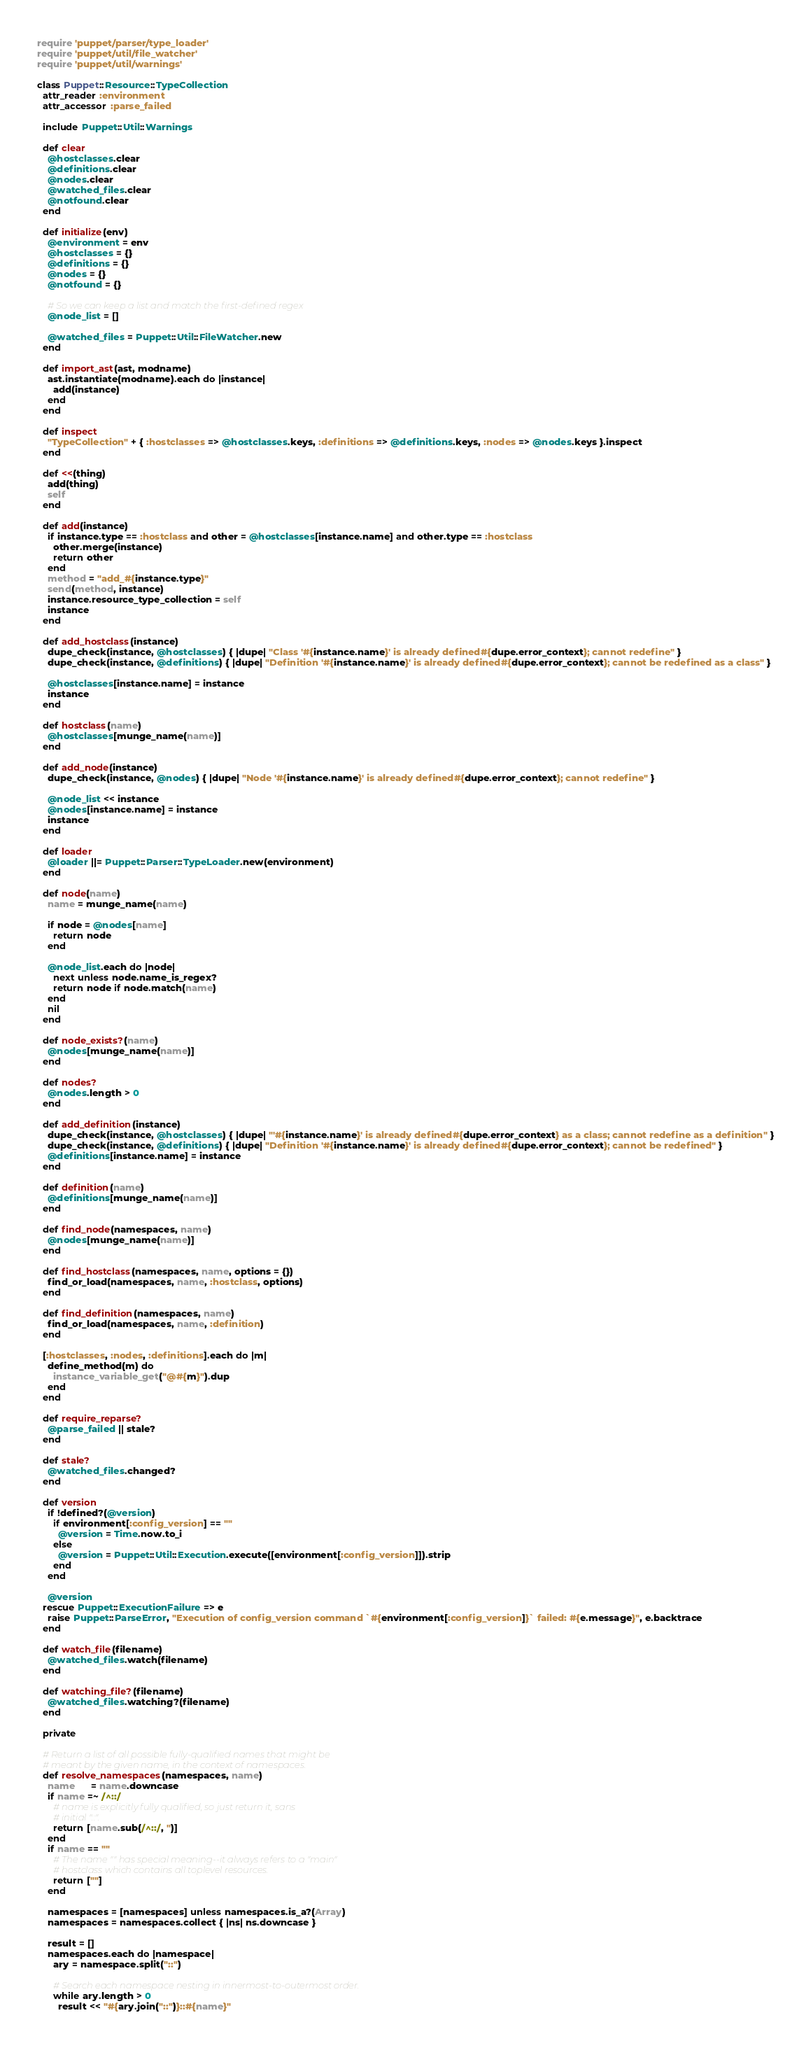<code> <loc_0><loc_0><loc_500><loc_500><_Ruby_>require 'puppet/parser/type_loader'
require 'puppet/util/file_watcher'
require 'puppet/util/warnings'

class Puppet::Resource::TypeCollection
  attr_reader :environment
  attr_accessor :parse_failed

  include Puppet::Util::Warnings

  def clear
    @hostclasses.clear
    @definitions.clear
    @nodes.clear
    @watched_files.clear
    @notfound.clear
  end

  def initialize(env)
    @environment = env
    @hostclasses = {}
    @definitions = {}
    @nodes = {}
    @notfound = {}

    # So we can keep a list and match the first-defined regex
    @node_list = []

    @watched_files = Puppet::Util::FileWatcher.new
  end

  def import_ast(ast, modname)
    ast.instantiate(modname).each do |instance|
      add(instance)
    end
  end

  def inspect
    "TypeCollection" + { :hostclasses => @hostclasses.keys, :definitions => @definitions.keys, :nodes => @nodes.keys }.inspect
  end

  def <<(thing)
    add(thing)
    self
  end

  def add(instance)
    if instance.type == :hostclass and other = @hostclasses[instance.name] and other.type == :hostclass
      other.merge(instance)
      return other
    end
    method = "add_#{instance.type}"
    send(method, instance)
    instance.resource_type_collection = self
    instance
  end

  def add_hostclass(instance)
    dupe_check(instance, @hostclasses) { |dupe| "Class '#{instance.name}' is already defined#{dupe.error_context}; cannot redefine" }
    dupe_check(instance, @definitions) { |dupe| "Definition '#{instance.name}' is already defined#{dupe.error_context}; cannot be redefined as a class" }

    @hostclasses[instance.name] = instance
    instance
  end

  def hostclass(name)
    @hostclasses[munge_name(name)]
  end

  def add_node(instance)
    dupe_check(instance, @nodes) { |dupe| "Node '#{instance.name}' is already defined#{dupe.error_context}; cannot redefine" }

    @node_list << instance
    @nodes[instance.name] = instance
    instance
  end

  def loader
    @loader ||= Puppet::Parser::TypeLoader.new(environment)
  end

  def node(name)
    name = munge_name(name)

    if node = @nodes[name]
      return node
    end

    @node_list.each do |node|
      next unless node.name_is_regex?
      return node if node.match(name)
    end
    nil
  end

  def node_exists?(name)
    @nodes[munge_name(name)]
  end

  def nodes?
    @nodes.length > 0
  end

  def add_definition(instance)
    dupe_check(instance, @hostclasses) { |dupe| "'#{instance.name}' is already defined#{dupe.error_context} as a class; cannot redefine as a definition" }
    dupe_check(instance, @definitions) { |dupe| "Definition '#{instance.name}' is already defined#{dupe.error_context}; cannot be redefined" }
    @definitions[instance.name] = instance
  end

  def definition(name)
    @definitions[munge_name(name)]
  end

  def find_node(namespaces, name)
    @nodes[munge_name(name)]
  end

  def find_hostclass(namespaces, name, options = {})
    find_or_load(namespaces, name, :hostclass, options)
  end

  def find_definition(namespaces, name)
    find_or_load(namespaces, name, :definition)
  end

  [:hostclasses, :nodes, :definitions].each do |m|
    define_method(m) do
      instance_variable_get("@#{m}").dup
    end
  end

  def require_reparse?
    @parse_failed || stale?
  end

  def stale?
    @watched_files.changed?
  end

  def version
    if !defined?(@version)
      if environment[:config_version] == ""
        @version = Time.now.to_i
      else
        @version = Puppet::Util::Execution.execute([environment[:config_version]]).strip
      end
    end

    @version
  rescue Puppet::ExecutionFailure => e
    raise Puppet::ParseError, "Execution of config_version command `#{environment[:config_version]}` failed: #{e.message}", e.backtrace
  end

  def watch_file(filename)
    @watched_files.watch(filename)
  end

  def watching_file?(filename)
    @watched_files.watching?(filename)
  end

  private

  # Return a list of all possible fully-qualified names that might be
  # meant by the given name, in the context of namespaces.
  def resolve_namespaces(namespaces, name)
    name      = name.downcase
    if name =~ /^::/
      # name is explicitly fully qualified, so just return it, sans
      # initial "::".
      return [name.sub(/^::/, '')]
    end
    if name == ""
      # The name "" has special meaning--it always refers to a "main"
      # hostclass which contains all toplevel resources.
      return [""]
    end

    namespaces = [namespaces] unless namespaces.is_a?(Array)
    namespaces = namespaces.collect { |ns| ns.downcase }

    result = []
    namespaces.each do |namespace|
      ary = namespace.split("::")

      # Search each namespace nesting in innermost-to-outermost order.
      while ary.length > 0
        result << "#{ary.join("::")}::#{name}"</code> 